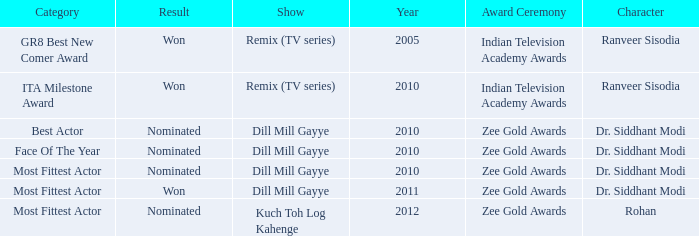Which show was nominated for the ITA Milestone Award at the Indian Television Academy Awards? Remix (TV series). 